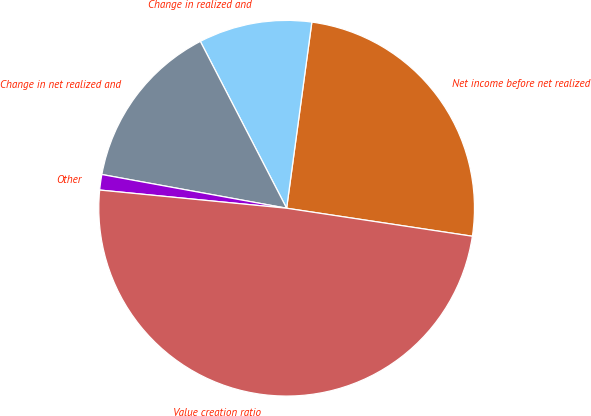Convert chart to OTSL. <chart><loc_0><loc_0><loc_500><loc_500><pie_chart><fcel>Net income before net realized<fcel>Change in realized and<fcel>Change in net realized and<fcel>Other<fcel>Value creation ratio<nl><fcel>25.24%<fcel>9.74%<fcel>14.53%<fcel>1.33%<fcel>49.16%<nl></chart> 